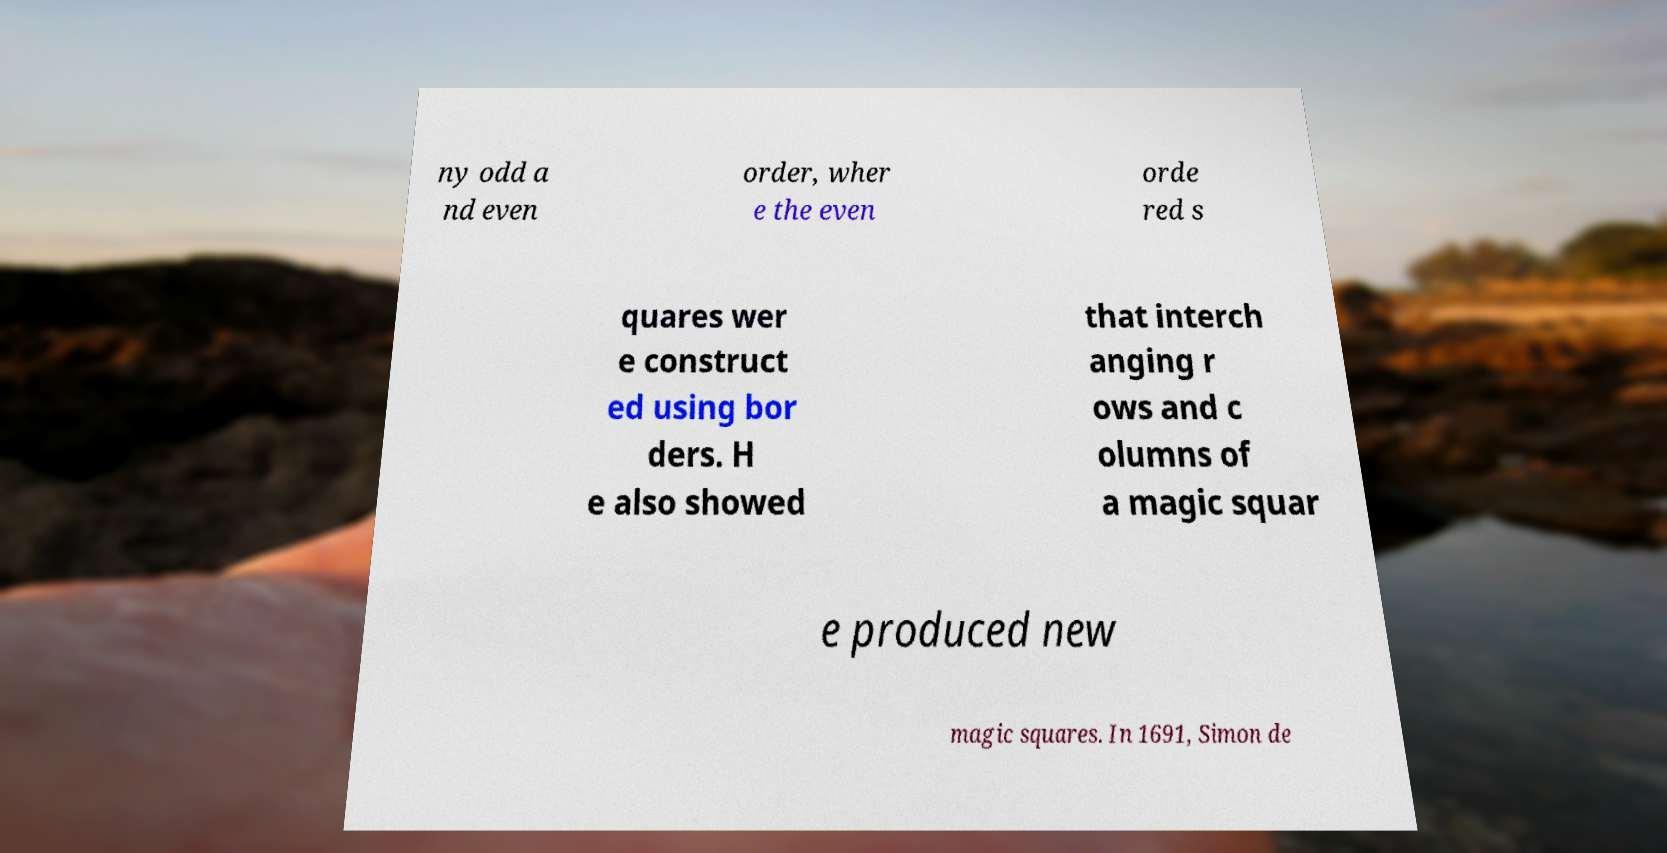I need the written content from this picture converted into text. Can you do that? ny odd a nd even order, wher e the even orde red s quares wer e construct ed using bor ders. H e also showed that interch anging r ows and c olumns of a magic squar e produced new magic squares. In 1691, Simon de 